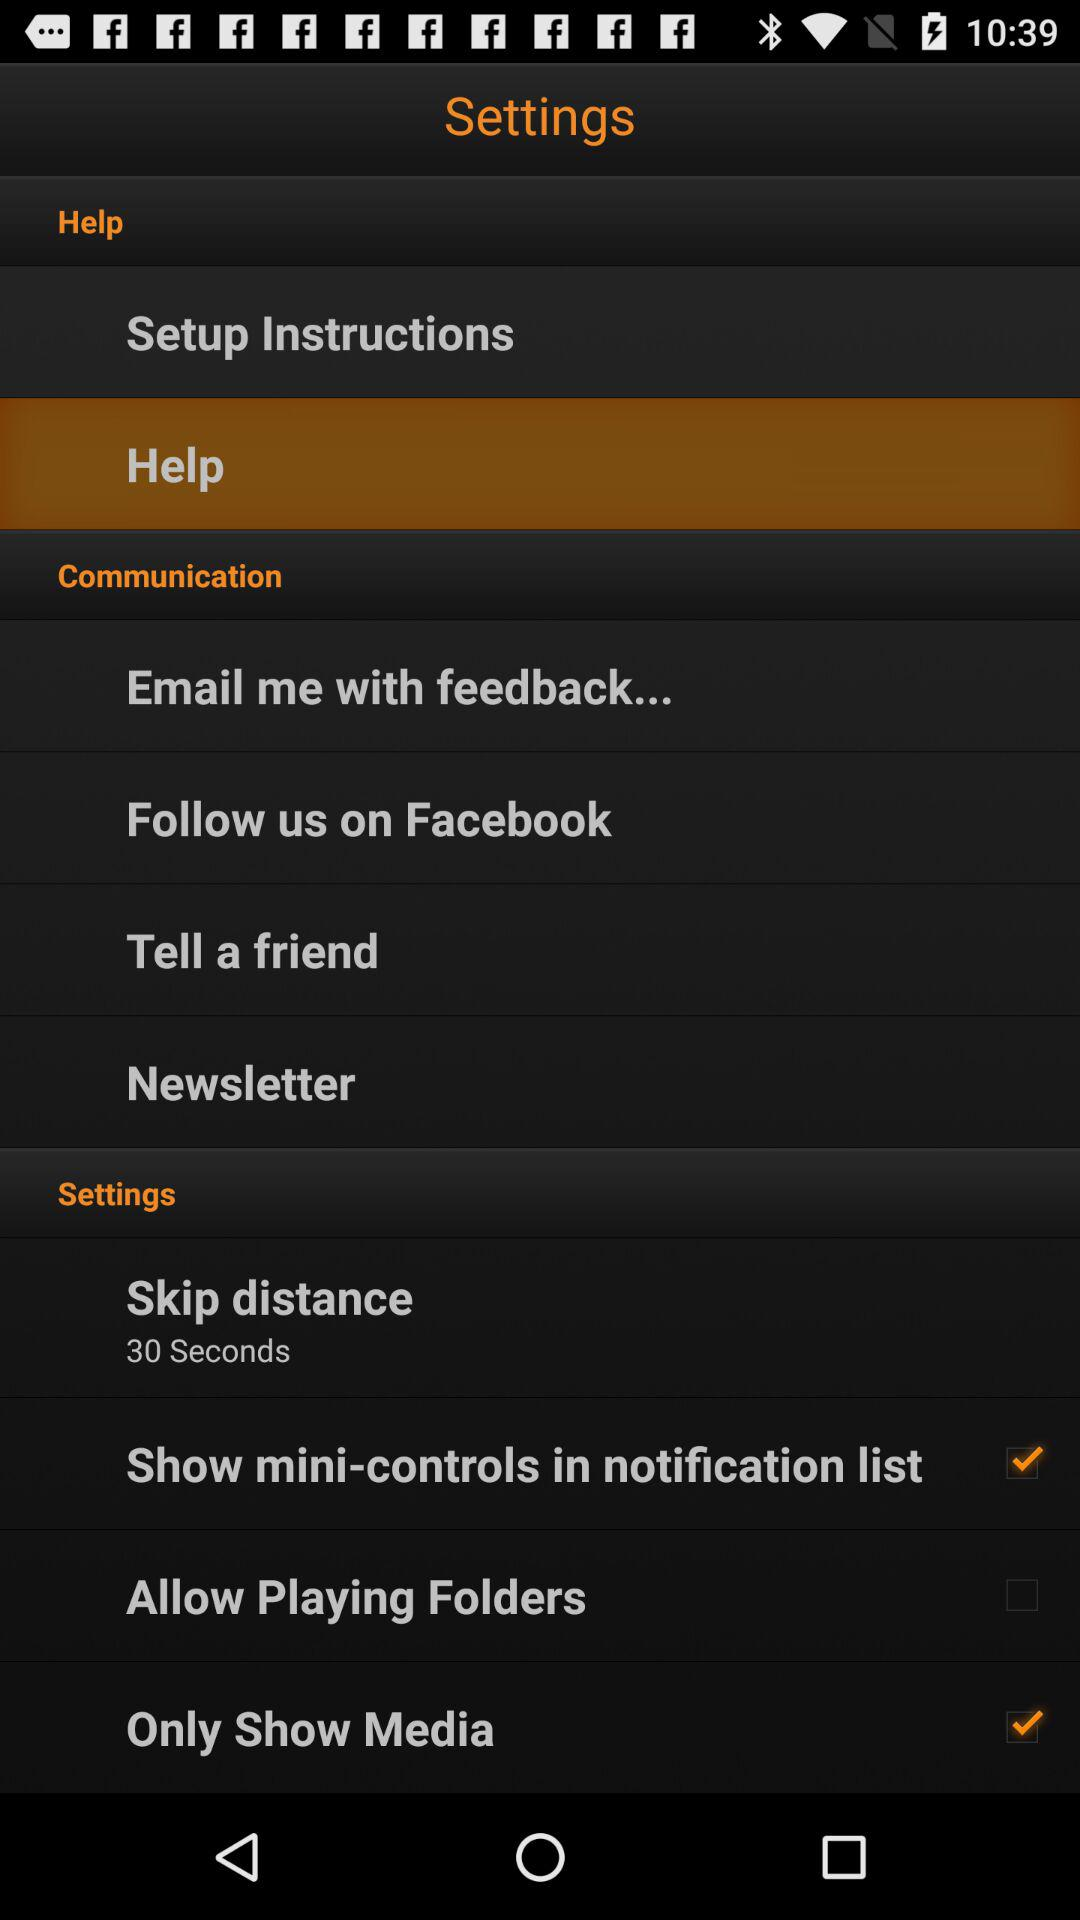How many items are in the Communication section?
Answer the question using a single word or phrase. 4 